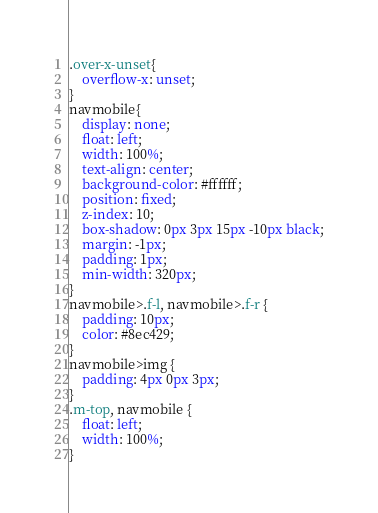Convert code to text. <code><loc_0><loc_0><loc_500><loc_500><_CSS_>.over-x-unset{
    overflow-x: unset;
}
navmobile{
    display: none;
    float: left;
    width: 100%;
    text-align: center;
    background-color: #ffffff;
    position: fixed;
    z-index: 10;
    box-shadow: 0px 3px 15px -10px black;
    margin: -1px;
    padding: 1px;
    min-width: 320px;
}
navmobile>.f-l, navmobile>.f-r {
    padding: 10px;
    color: #8ec429;
}
navmobile>img {
    padding: 4px 0px 3px;
}
.m-top, navmobile {
    float: left;
    width: 100%;
}</code> 